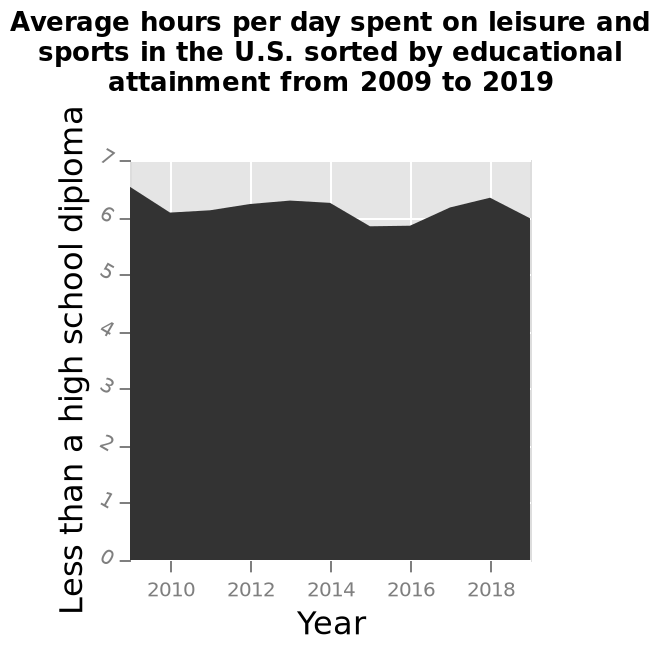<image>
please summary the statistics and relations of the chart The chart shows the highest number of hours spent per day on leisure and sports was in 2009 with 6.5 average hours. The lowest number of hours spent per day on leisure and sports was in 2015 and 2016 with just under 6 average hours. 